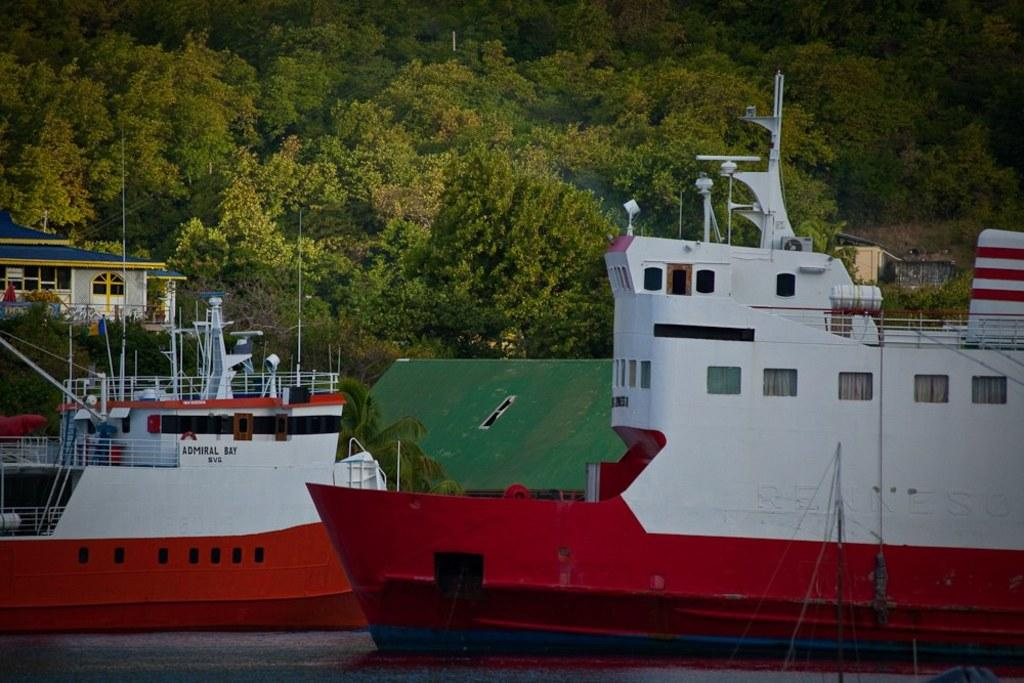What can be seen in the image that is used for transportation on water? There are two ships in the image. What body of water are the ships traveling on? There is a river at the bottom of the image. What type of vegetation is visible in the background of the image? There are trees in the background of the image. What type of structure can be seen in the background of the image? There is a house in the background of the image. Where is the poisonous cart located in the image? There is no cart, poisonous or otherwise, present in the image. What type of bird's nest can be seen in the image? There is no bird's nest visible in the image. 